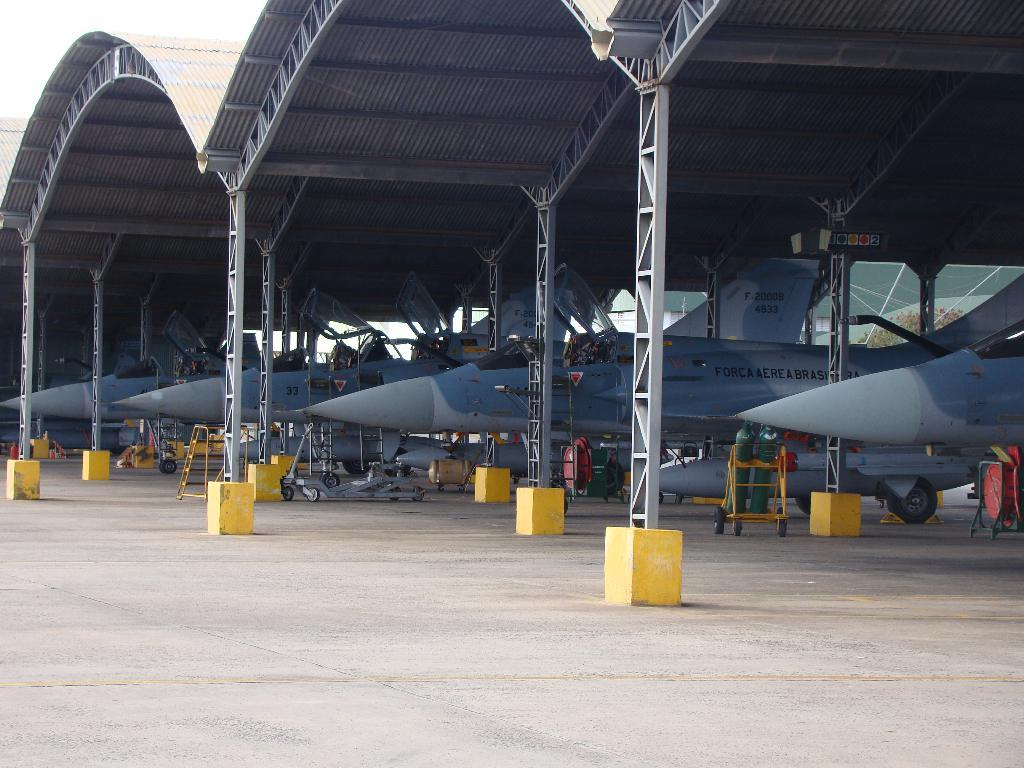Provide a one-sentence caption for the provided image. Four jets are sitting in an airplane hanger one of which is number 33. 